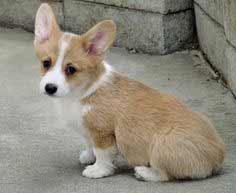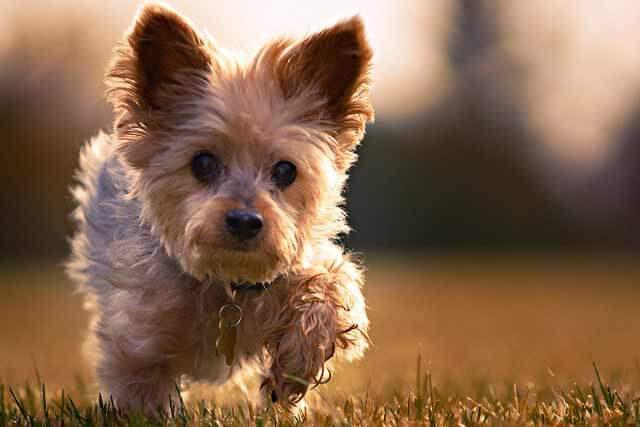The first image is the image on the left, the second image is the image on the right. For the images shown, is this caption "In at least one of the photos, a dog's body is facing left." true? Answer yes or no. Yes. 